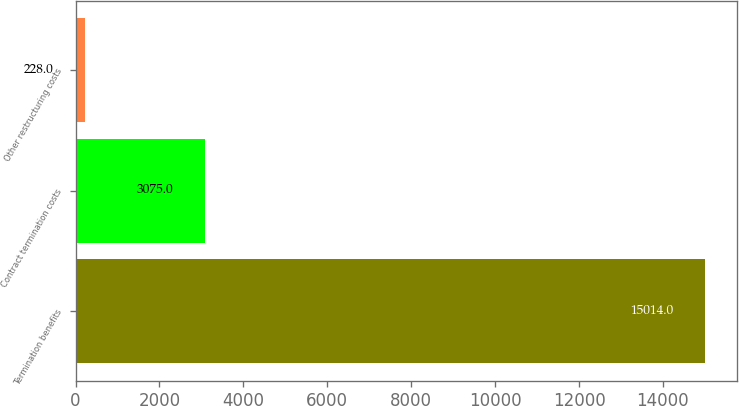<chart> <loc_0><loc_0><loc_500><loc_500><bar_chart><fcel>Termination benefits<fcel>Contract termination costs<fcel>Other restructuring costs<nl><fcel>15014<fcel>3075<fcel>228<nl></chart> 